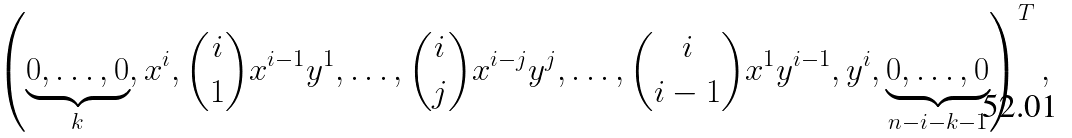Convert formula to latex. <formula><loc_0><loc_0><loc_500><loc_500>\left ( \underbrace { 0 , \dots , 0 } _ { k } , x ^ { i } , \binom { i } { 1 } x ^ { i - 1 } y ^ { 1 } , \dots , \binom { i } { j } x ^ { i - j } y ^ { j } , \dots , \binom { i } { i - 1 } x ^ { 1 } y ^ { i - 1 } , y ^ { i } , \underbrace { 0 , \dots , 0 } _ { n - i - k - 1 } \right ) ^ { T } ,</formula> 